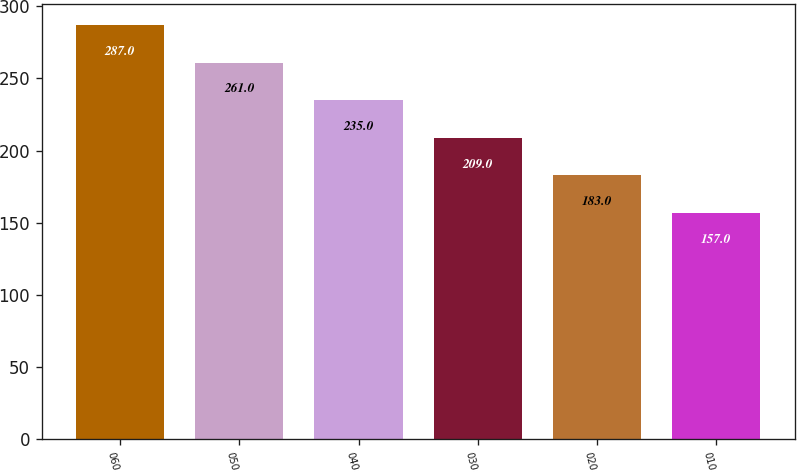Convert chart. <chart><loc_0><loc_0><loc_500><loc_500><bar_chart><fcel>060<fcel>050<fcel>040<fcel>030<fcel>020<fcel>010<nl><fcel>287<fcel>261<fcel>235<fcel>209<fcel>183<fcel>157<nl></chart> 